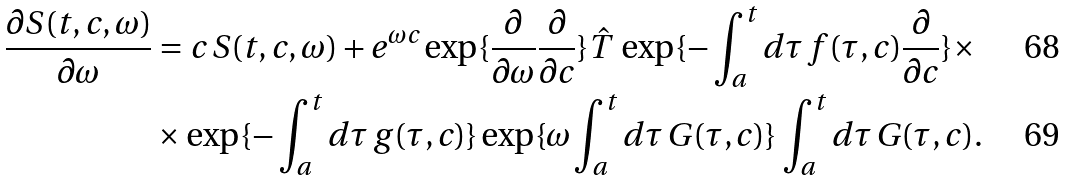Convert formula to latex. <formula><loc_0><loc_0><loc_500><loc_500>\frac { \partial S ( t , c , \omega ) } { \partial \omega } & = c \, S ( t , c , \omega ) + e ^ { \omega c } \exp \{ \frac { \partial } { \partial \omega } \frac { \partial } { \partial c } \} \hat { T } \, \exp \{ - \int _ { a } ^ { t } d \tau \, f ( \tau , c ) \frac { \partial } { \partial c } \} \times \\ & \times \exp \{ - \int _ { a } ^ { t } d \tau \, g ( \tau , c ) \} \exp \{ \omega \int _ { a } ^ { t } d \tau \, G ( \tau , c ) \} \, \int _ { a } ^ { t } d \tau \, G ( \tau , c ) .</formula> 